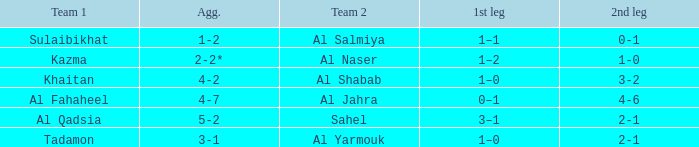What is the first leg for al fahaheel team 1? 0–1. 